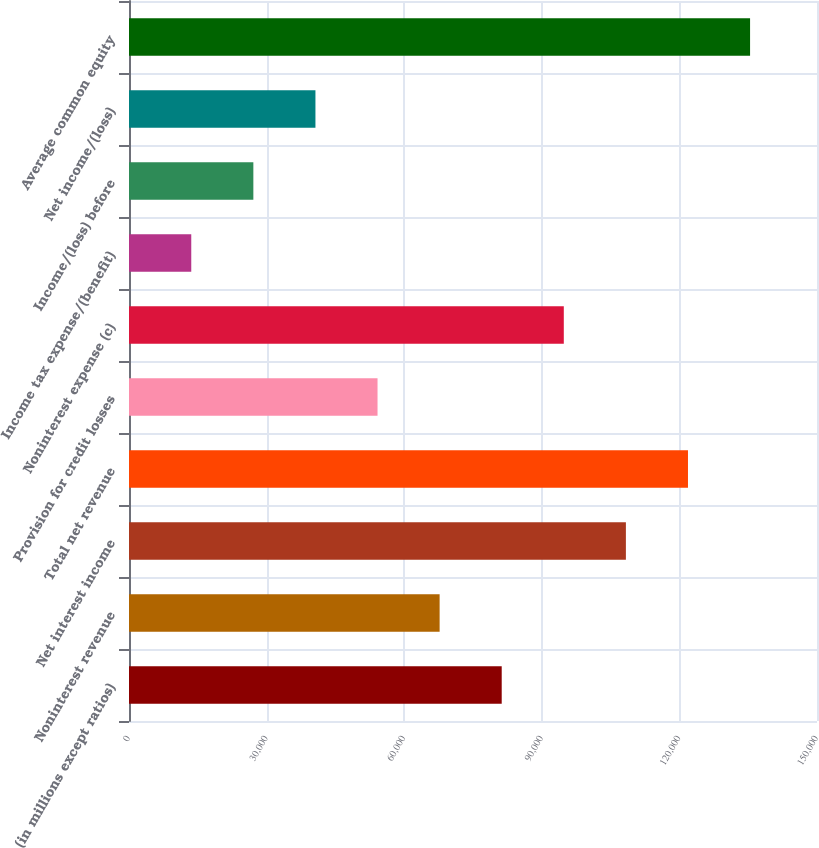Convert chart. <chart><loc_0><loc_0><loc_500><loc_500><bar_chart><fcel>(in millions except ratios)<fcel>Noninterest revenue<fcel>Net interest income<fcel>Total net revenue<fcel>Provision for credit losses<fcel>Noninterest expense (c)<fcel>Income tax expense/(benefit)<fcel>Income/(loss) before<fcel>Net income/(loss)<fcel>Average common equity<nl><fcel>81260<fcel>67723<fcel>108334<fcel>121871<fcel>54186<fcel>94797<fcel>13575<fcel>27112<fcel>40649<fcel>135408<nl></chart> 